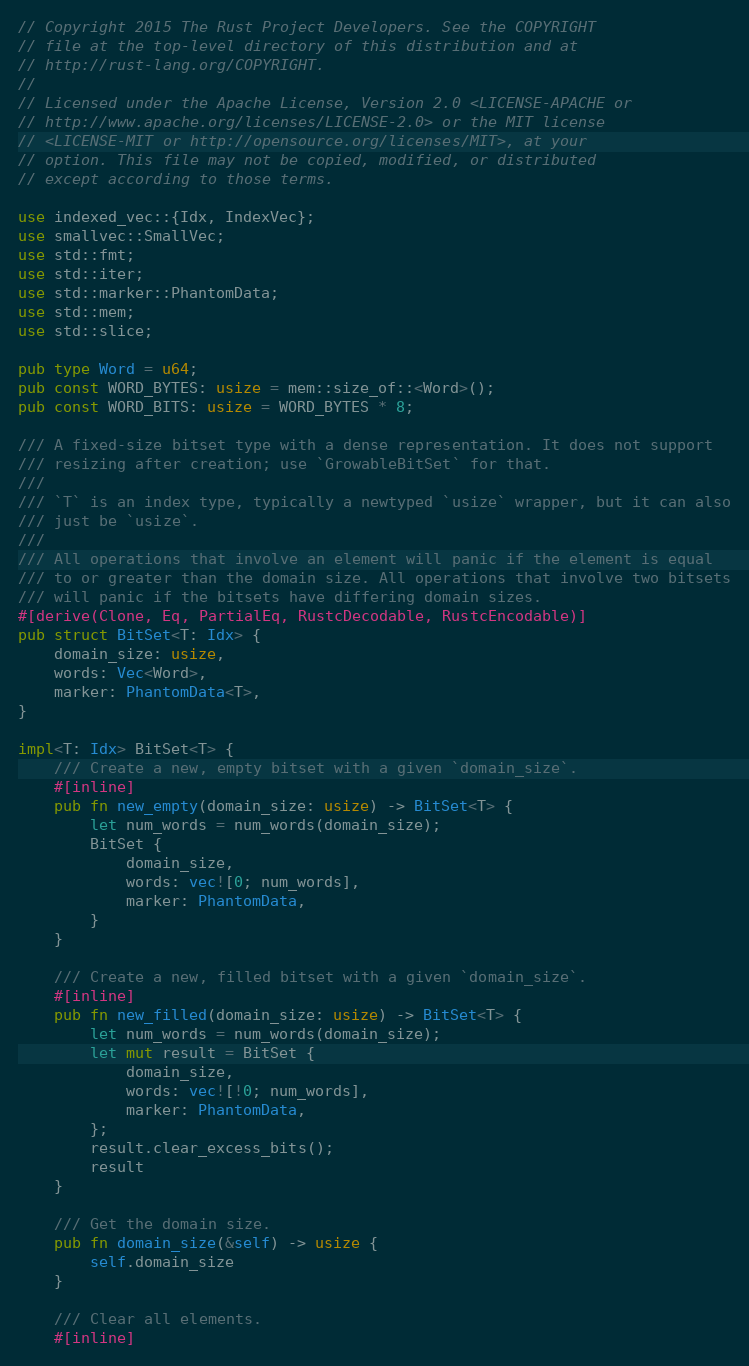<code> <loc_0><loc_0><loc_500><loc_500><_Rust_>// Copyright 2015 The Rust Project Developers. See the COPYRIGHT
// file at the top-level directory of this distribution and at
// http://rust-lang.org/COPYRIGHT.
//
// Licensed under the Apache License, Version 2.0 <LICENSE-APACHE or
// http://www.apache.org/licenses/LICENSE-2.0> or the MIT license
// <LICENSE-MIT or http://opensource.org/licenses/MIT>, at your
// option. This file may not be copied, modified, or distributed
// except according to those terms.

use indexed_vec::{Idx, IndexVec};
use smallvec::SmallVec;
use std::fmt;
use std::iter;
use std::marker::PhantomData;
use std::mem;
use std::slice;

pub type Word = u64;
pub const WORD_BYTES: usize = mem::size_of::<Word>();
pub const WORD_BITS: usize = WORD_BYTES * 8;

/// A fixed-size bitset type with a dense representation. It does not support
/// resizing after creation; use `GrowableBitSet` for that.
///
/// `T` is an index type, typically a newtyped `usize` wrapper, but it can also
/// just be `usize`.
///
/// All operations that involve an element will panic if the element is equal
/// to or greater than the domain size. All operations that involve two bitsets
/// will panic if the bitsets have differing domain sizes.
#[derive(Clone, Eq, PartialEq, RustcDecodable, RustcEncodable)]
pub struct BitSet<T: Idx> {
    domain_size: usize,
    words: Vec<Word>,
    marker: PhantomData<T>,
}

impl<T: Idx> BitSet<T> {
    /// Create a new, empty bitset with a given `domain_size`.
    #[inline]
    pub fn new_empty(domain_size: usize) -> BitSet<T> {
        let num_words = num_words(domain_size);
        BitSet {
            domain_size,
            words: vec![0; num_words],
            marker: PhantomData,
        }
    }

    /// Create a new, filled bitset with a given `domain_size`.
    #[inline]
    pub fn new_filled(domain_size: usize) -> BitSet<T> {
        let num_words = num_words(domain_size);
        let mut result = BitSet {
            domain_size,
            words: vec![!0; num_words],
            marker: PhantomData,
        };
        result.clear_excess_bits();
        result
    }

    /// Get the domain size.
    pub fn domain_size(&self) -> usize {
        self.domain_size
    }

    /// Clear all elements.
    #[inline]</code> 